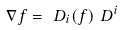Convert formula to latex. <formula><loc_0><loc_0><loc_500><loc_500>\nabla f = \ D _ { i } ( f ) \ D ^ { i }</formula> 